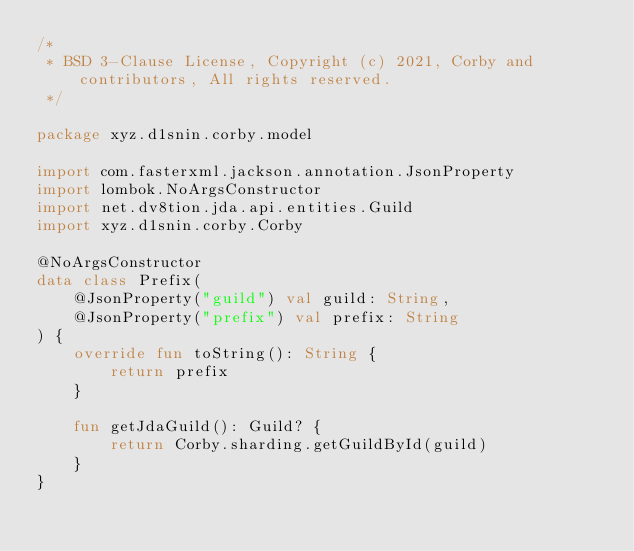Convert code to text. <code><loc_0><loc_0><loc_500><loc_500><_Kotlin_>/*
 * BSD 3-Clause License, Copyright (c) 2021, Corby and contributors, All rights reserved.
 */

package xyz.d1snin.corby.model

import com.fasterxml.jackson.annotation.JsonProperty
import lombok.NoArgsConstructor
import net.dv8tion.jda.api.entities.Guild
import xyz.d1snin.corby.Corby

@NoArgsConstructor
data class Prefix(
    @JsonProperty("guild") val guild: String,
    @JsonProperty("prefix") val prefix: String
) {
    override fun toString(): String {
        return prefix
    }

    fun getJdaGuild(): Guild? {
        return Corby.sharding.getGuildById(guild)
    }
}
</code> 